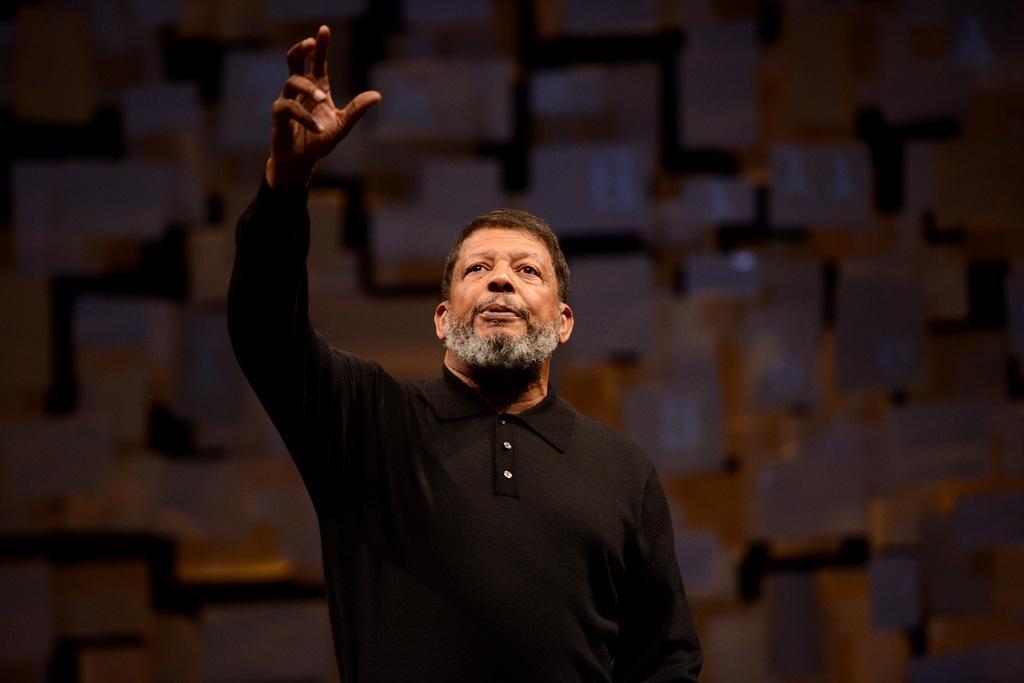Describe this image in one or two sentences. In this image I can see a man and I can see he is wearing black t shirt. I can see this image is little bit blurry from background. 